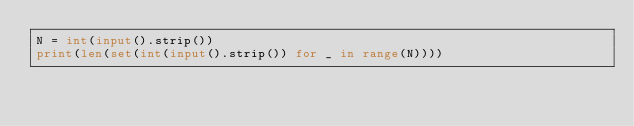<code> <loc_0><loc_0><loc_500><loc_500><_Python_>N = int(input().strip())
print(len(set(int(input().strip()) for _ in range(N))))
</code> 